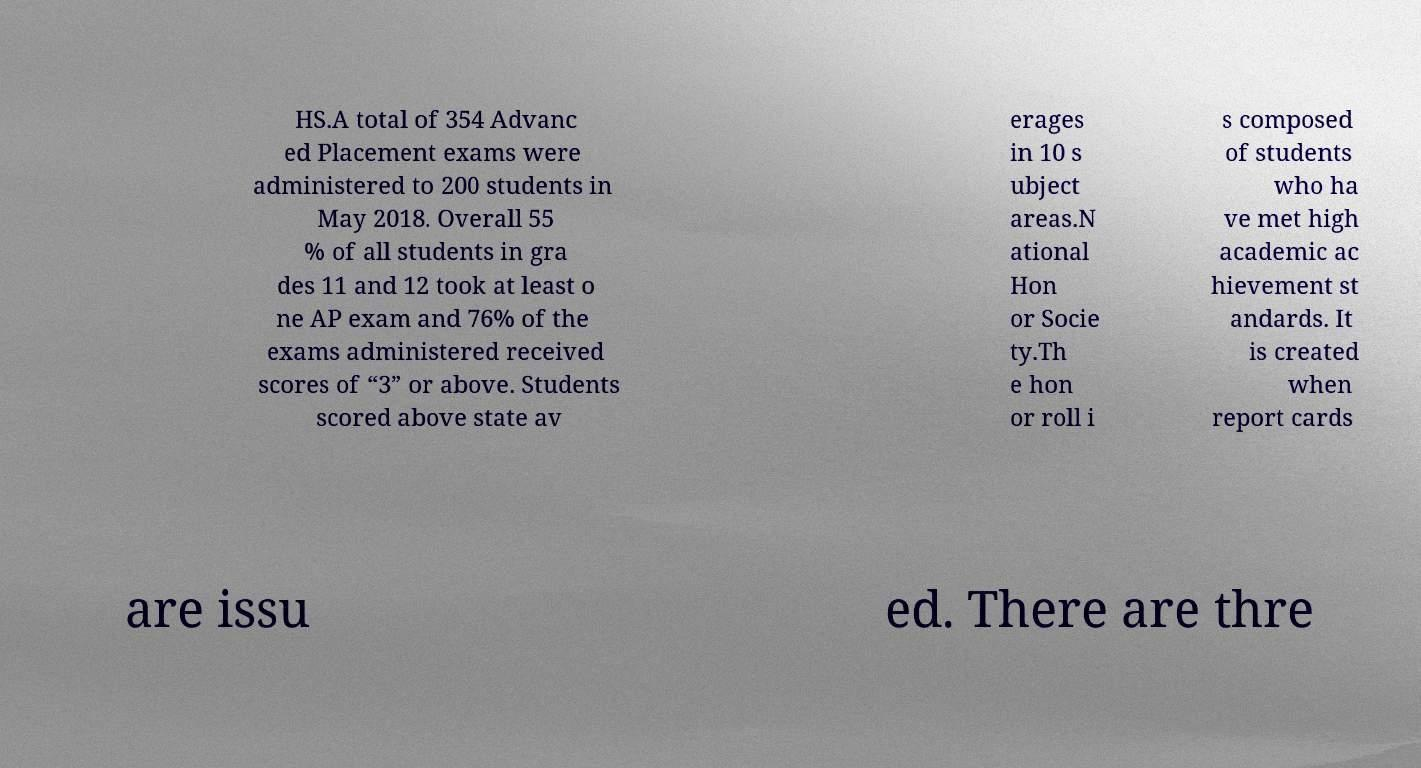There's text embedded in this image that I need extracted. Can you transcribe it verbatim? HS.A total of 354 Advanc ed Placement exams were administered to 200 students in May 2018. Overall 55 % of all students in gra des 11 and 12 took at least o ne AP exam and 76% of the exams administered received scores of “3” or above. Students scored above state av erages in 10 s ubject areas.N ational Hon or Socie ty.Th e hon or roll i s composed of students who ha ve met high academic ac hievement st andards. It is created when report cards are issu ed. There are thre 